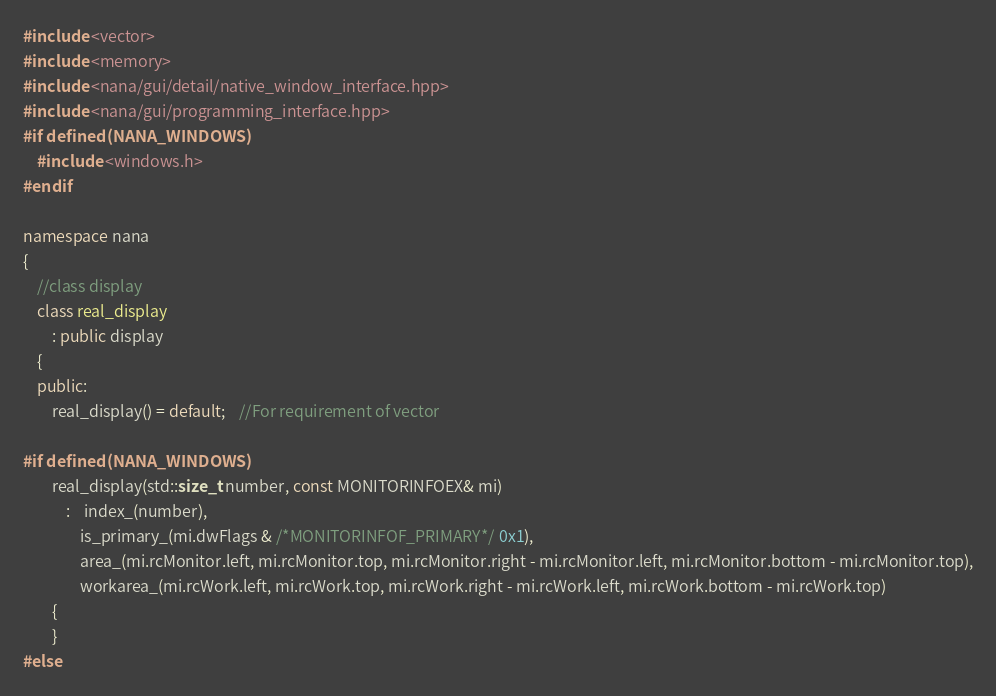Convert code to text. <code><loc_0><loc_0><loc_500><loc_500><_C++_>#include <vector>
#include <memory>
#include <nana/gui/detail/native_window_interface.hpp>
#include <nana/gui/programming_interface.hpp>
#if defined(NANA_WINDOWS)
	#include <windows.h>
#endif

namespace nana
{
	//class display
	class real_display
		: public display
	{
	public:
		real_display() = default;	//For requirement of vector

#if defined(NANA_WINDOWS)
		real_display(std::size_t number, const MONITORINFOEX& mi)
			:	index_(number),
				is_primary_(mi.dwFlags & /*MONITORINFOF_PRIMARY*/ 0x1),
				area_(mi.rcMonitor.left, mi.rcMonitor.top, mi.rcMonitor.right - mi.rcMonitor.left, mi.rcMonitor.bottom - mi.rcMonitor.top),
				workarea_(mi.rcWork.left, mi.rcWork.top, mi.rcWork.right - mi.rcWork.left, mi.rcWork.bottom - mi.rcWork.top)
		{
		}
#else</code> 